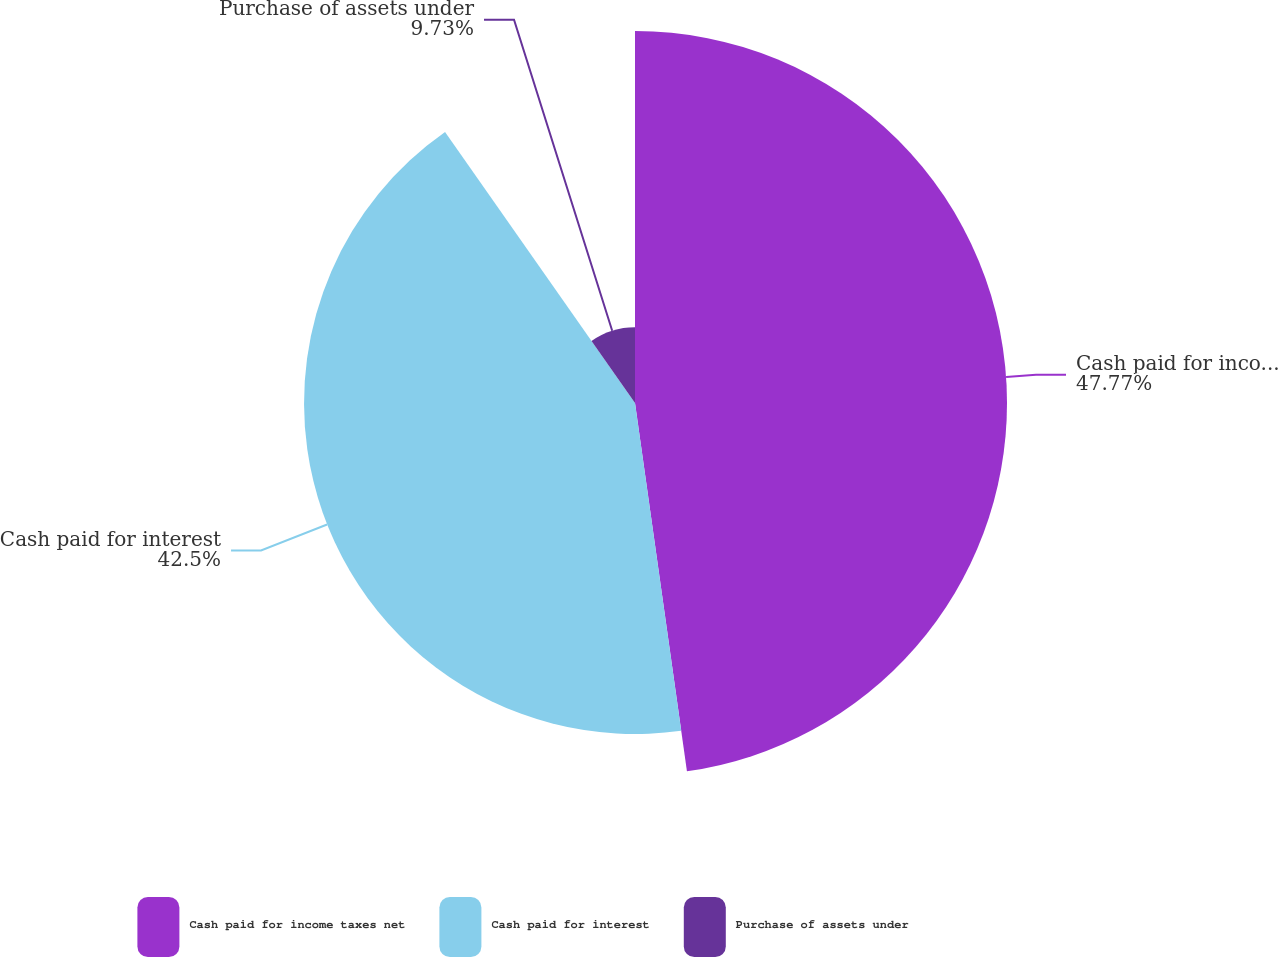Convert chart to OTSL. <chart><loc_0><loc_0><loc_500><loc_500><pie_chart><fcel>Cash paid for income taxes net<fcel>Cash paid for interest<fcel>Purchase of assets under<nl><fcel>47.77%<fcel>42.5%<fcel>9.73%<nl></chart> 